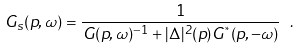Convert formula to latex. <formula><loc_0><loc_0><loc_500><loc_500>G _ { s } ( p , \omega ) = \frac { 1 } { G ( p , \omega ) ^ { - 1 } + | \Delta | ^ { 2 } ( p ) G ^ { ^ { * } } ( p , - \omega ) } \ .</formula> 